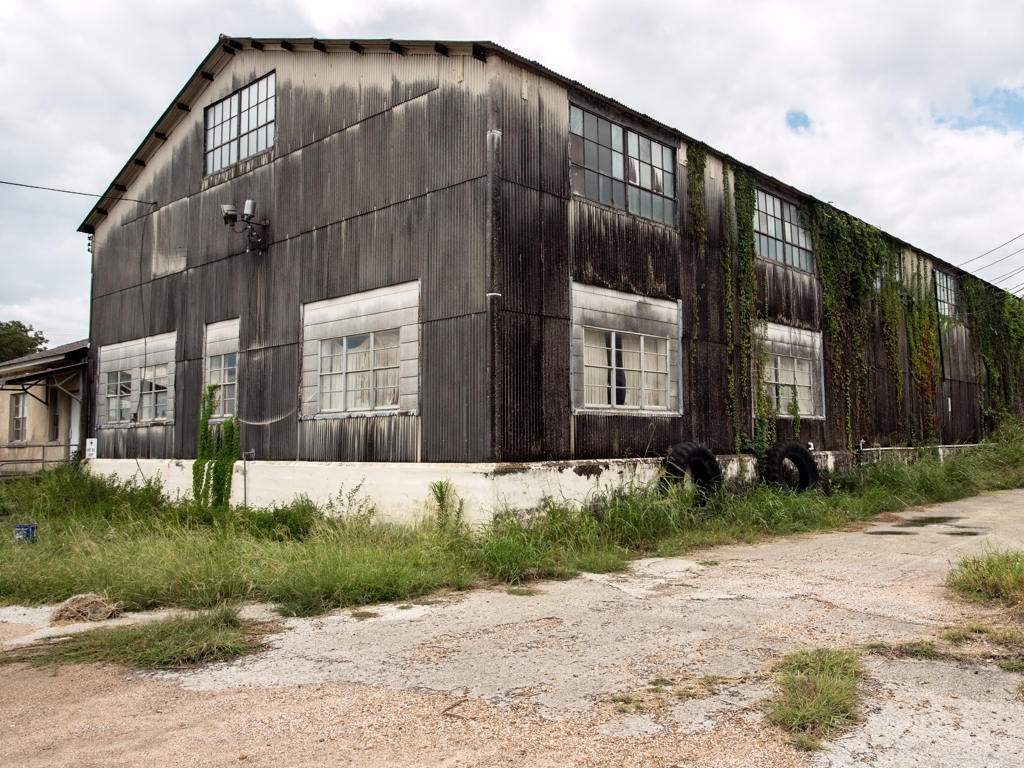What does the surrounding environment suggest about the location? The surrounding area of the building shows signs of wear and minimal upkeep, with overgrown grass and a lack of human activity. The industrial nature of the structure, combined with the lack of maintenance, suggests it may be located in a less-populated area or an industrial section of a city that has seen better days. It's plausible that the area is undergoing economic transitions or urban decline. 